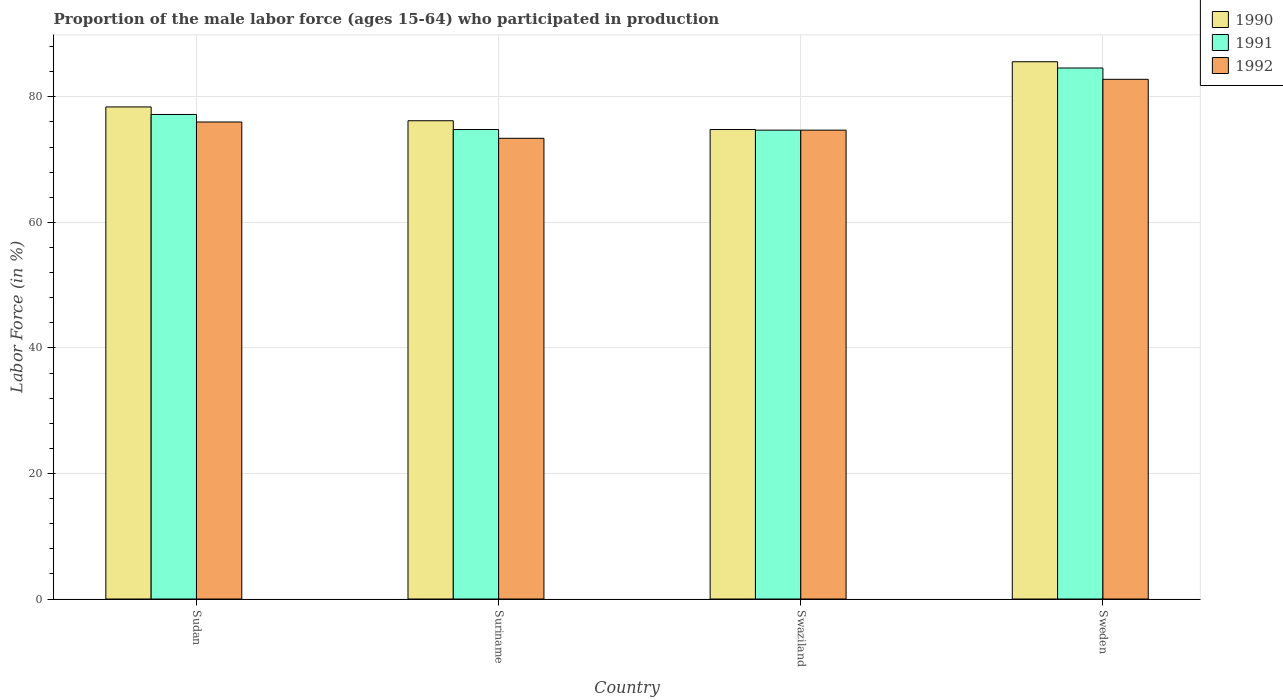How many groups of bars are there?
Your response must be concise. 4. How many bars are there on the 1st tick from the left?
Offer a terse response. 3. How many bars are there on the 4th tick from the right?
Give a very brief answer. 3. What is the proportion of the male labor force who participated in production in 1990 in Sweden?
Offer a very short reply. 85.6. Across all countries, what is the maximum proportion of the male labor force who participated in production in 1990?
Provide a succinct answer. 85.6. Across all countries, what is the minimum proportion of the male labor force who participated in production in 1990?
Offer a very short reply. 74.8. In which country was the proportion of the male labor force who participated in production in 1990 maximum?
Your response must be concise. Sweden. In which country was the proportion of the male labor force who participated in production in 1990 minimum?
Make the answer very short. Swaziland. What is the total proportion of the male labor force who participated in production in 1991 in the graph?
Your answer should be compact. 311.3. What is the difference between the proportion of the male labor force who participated in production in 1991 in Suriname and that in Sweden?
Offer a terse response. -9.8. What is the difference between the proportion of the male labor force who participated in production in 1990 in Sudan and the proportion of the male labor force who participated in production in 1991 in Suriname?
Offer a terse response. 3.6. What is the average proportion of the male labor force who participated in production in 1992 per country?
Offer a terse response. 76.73. What is the difference between the proportion of the male labor force who participated in production of/in 1991 and proportion of the male labor force who participated in production of/in 1992 in Sweden?
Provide a succinct answer. 1.8. What is the ratio of the proportion of the male labor force who participated in production in 1991 in Sudan to that in Swaziland?
Offer a terse response. 1.03. Is the proportion of the male labor force who participated in production in 1992 in Sudan less than that in Swaziland?
Keep it short and to the point. No. What is the difference between the highest and the second highest proportion of the male labor force who participated in production in 1991?
Provide a short and direct response. -9.8. What is the difference between the highest and the lowest proportion of the male labor force who participated in production in 1991?
Your response must be concise. 9.9. Is the sum of the proportion of the male labor force who participated in production in 1991 in Suriname and Sweden greater than the maximum proportion of the male labor force who participated in production in 1992 across all countries?
Give a very brief answer. Yes. What does the 1st bar from the left in Swaziland represents?
Make the answer very short. 1990. What does the 2nd bar from the right in Swaziland represents?
Your response must be concise. 1991. Is it the case that in every country, the sum of the proportion of the male labor force who participated in production in 1990 and proportion of the male labor force who participated in production in 1991 is greater than the proportion of the male labor force who participated in production in 1992?
Make the answer very short. Yes. How many countries are there in the graph?
Keep it short and to the point. 4. Where does the legend appear in the graph?
Offer a very short reply. Top right. How are the legend labels stacked?
Your response must be concise. Vertical. What is the title of the graph?
Your answer should be very brief. Proportion of the male labor force (ages 15-64) who participated in production. Does "2004" appear as one of the legend labels in the graph?
Your answer should be compact. No. What is the label or title of the Y-axis?
Provide a short and direct response. Labor Force (in %). What is the Labor Force (in %) of 1990 in Sudan?
Offer a very short reply. 78.4. What is the Labor Force (in %) of 1991 in Sudan?
Ensure brevity in your answer.  77.2. What is the Labor Force (in %) of 1990 in Suriname?
Make the answer very short. 76.2. What is the Labor Force (in %) of 1991 in Suriname?
Provide a succinct answer. 74.8. What is the Labor Force (in %) in 1992 in Suriname?
Give a very brief answer. 73.4. What is the Labor Force (in %) in 1990 in Swaziland?
Your answer should be very brief. 74.8. What is the Labor Force (in %) of 1991 in Swaziland?
Give a very brief answer. 74.7. What is the Labor Force (in %) in 1992 in Swaziland?
Offer a very short reply. 74.7. What is the Labor Force (in %) of 1990 in Sweden?
Your answer should be very brief. 85.6. What is the Labor Force (in %) of 1991 in Sweden?
Ensure brevity in your answer.  84.6. What is the Labor Force (in %) of 1992 in Sweden?
Your answer should be compact. 82.8. Across all countries, what is the maximum Labor Force (in %) of 1990?
Give a very brief answer. 85.6. Across all countries, what is the maximum Labor Force (in %) in 1991?
Provide a short and direct response. 84.6. Across all countries, what is the maximum Labor Force (in %) of 1992?
Your answer should be compact. 82.8. Across all countries, what is the minimum Labor Force (in %) in 1990?
Your answer should be compact. 74.8. Across all countries, what is the minimum Labor Force (in %) in 1991?
Ensure brevity in your answer.  74.7. Across all countries, what is the minimum Labor Force (in %) in 1992?
Offer a terse response. 73.4. What is the total Labor Force (in %) of 1990 in the graph?
Provide a succinct answer. 315. What is the total Labor Force (in %) of 1991 in the graph?
Provide a short and direct response. 311.3. What is the total Labor Force (in %) of 1992 in the graph?
Make the answer very short. 306.9. What is the difference between the Labor Force (in %) of 1992 in Sudan and that in Suriname?
Give a very brief answer. 2.6. What is the difference between the Labor Force (in %) in 1992 in Sudan and that in Swaziland?
Offer a terse response. 1.3. What is the difference between the Labor Force (in %) in 1992 in Sudan and that in Sweden?
Offer a very short reply. -6.8. What is the difference between the Labor Force (in %) in 1990 in Suriname and that in Swaziland?
Your answer should be compact. 1.4. What is the difference between the Labor Force (in %) in 1991 in Suriname and that in Swaziland?
Your response must be concise. 0.1. What is the difference between the Labor Force (in %) of 1992 in Suriname and that in Swaziland?
Your answer should be compact. -1.3. What is the difference between the Labor Force (in %) of 1991 in Suriname and that in Sweden?
Offer a very short reply. -9.8. What is the difference between the Labor Force (in %) of 1992 in Suriname and that in Sweden?
Your response must be concise. -9.4. What is the difference between the Labor Force (in %) of 1990 in Swaziland and that in Sweden?
Keep it short and to the point. -10.8. What is the difference between the Labor Force (in %) of 1991 in Swaziland and that in Sweden?
Provide a short and direct response. -9.9. What is the difference between the Labor Force (in %) in 1992 in Swaziland and that in Sweden?
Your response must be concise. -8.1. What is the difference between the Labor Force (in %) of 1990 in Sudan and the Labor Force (in %) of 1992 in Swaziland?
Keep it short and to the point. 3.7. What is the difference between the Labor Force (in %) in 1990 in Sudan and the Labor Force (in %) in 1991 in Sweden?
Make the answer very short. -6.2. What is the difference between the Labor Force (in %) in 1991 in Suriname and the Labor Force (in %) in 1992 in Swaziland?
Provide a succinct answer. 0.1. What is the difference between the Labor Force (in %) in 1991 in Swaziland and the Labor Force (in %) in 1992 in Sweden?
Your answer should be compact. -8.1. What is the average Labor Force (in %) of 1990 per country?
Provide a short and direct response. 78.75. What is the average Labor Force (in %) of 1991 per country?
Your answer should be compact. 77.83. What is the average Labor Force (in %) of 1992 per country?
Keep it short and to the point. 76.72. What is the difference between the Labor Force (in %) in 1991 and Labor Force (in %) in 1992 in Sudan?
Your answer should be compact. 1.2. What is the difference between the Labor Force (in %) in 1990 and Labor Force (in %) in 1991 in Suriname?
Offer a very short reply. 1.4. What is the difference between the Labor Force (in %) of 1990 and Labor Force (in %) of 1992 in Suriname?
Keep it short and to the point. 2.8. What is the difference between the Labor Force (in %) of 1990 and Labor Force (in %) of 1992 in Swaziland?
Your answer should be compact. 0.1. What is the difference between the Labor Force (in %) in 1990 and Labor Force (in %) in 1991 in Sweden?
Give a very brief answer. 1. What is the difference between the Labor Force (in %) in 1990 and Labor Force (in %) in 1992 in Sweden?
Your response must be concise. 2.8. What is the ratio of the Labor Force (in %) in 1990 in Sudan to that in Suriname?
Make the answer very short. 1.03. What is the ratio of the Labor Force (in %) of 1991 in Sudan to that in Suriname?
Provide a short and direct response. 1.03. What is the ratio of the Labor Force (in %) of 1992 in Sudan to that in Suriname?
Offer a very short reply. 1.04. What is the ratio of the Labor Force (in %) in 1990 in Sudan to that in Swaziland?
Keep it short and to the point. 1.05. What is the ratio of the Labor Force (in %) of 1991 in Sudan to that in Swaziland?
Ensure brevity in your answer.  1.03. What is the ratio of the Labor Force (in %) in 1992 in Sudan to that in Swaziland?
Offer a terse response. 1.02. What is the ratio of the Labor Force (in %) in 1990 in Sudan to that in Sweden?
Make the answer very short. 0.92. What is the ratio of the Labor Force (in %) in 1991 in Sudan to that in Sweden?
Offer a terse response. 0.91. What is the ratio of the Labor Force (in %) in 1992 in Sudan to that in Sweden?
Your answer should be compact. 0.92. What is the ratio of the Labor Force (in %) of 1990 in Suriname to that in Swaziland?
Make the answer very short. 1.02. What is the ratio of the Labor Force (in %) of 1991 in Suriname to that in Swaziland?
Your answer should be very brief. 1. What is the ratio of the Labor Force (in %) of 1992 in Suriname to that in Swaziland?
Offer a terse response. 0.98. What is the ratio of the Labor Force (in %) in 1990 in Suriname to that in Sweden?
Offer a terse response. 0.89. What is the ratio of the Labor Force (in %) of 1991 in Suriname to that in Sweden?
Keep it short and to the point. 0.88. What is the ratio of the Labor Force (in %) in 1992 in Suriname to that in Sweden?
Offer a very short reply. 0.89. What is the ratio of the Labor Force (in %) in 1990 in Swaziland to that in Sweden?
Your answer should be very brief. 0.87. What is the ratio of the Labor Force (in %) in 1991 in Swaziland to that in Sweden?
Your answer should be compact. 0.88. What is the ratio of the Labor Force (in %) in 1992 in Swaziland to that in Sweden?
Provide a short and direct response. 0.9. What is the difference between the highest and the second highest Labor Force (in %) of 1990?
Give a very brief answer. 7.2. What is the difference between the highest and the lowest Labor Force (in %) of 1990?
Provide a succinct answer. 10.8. 